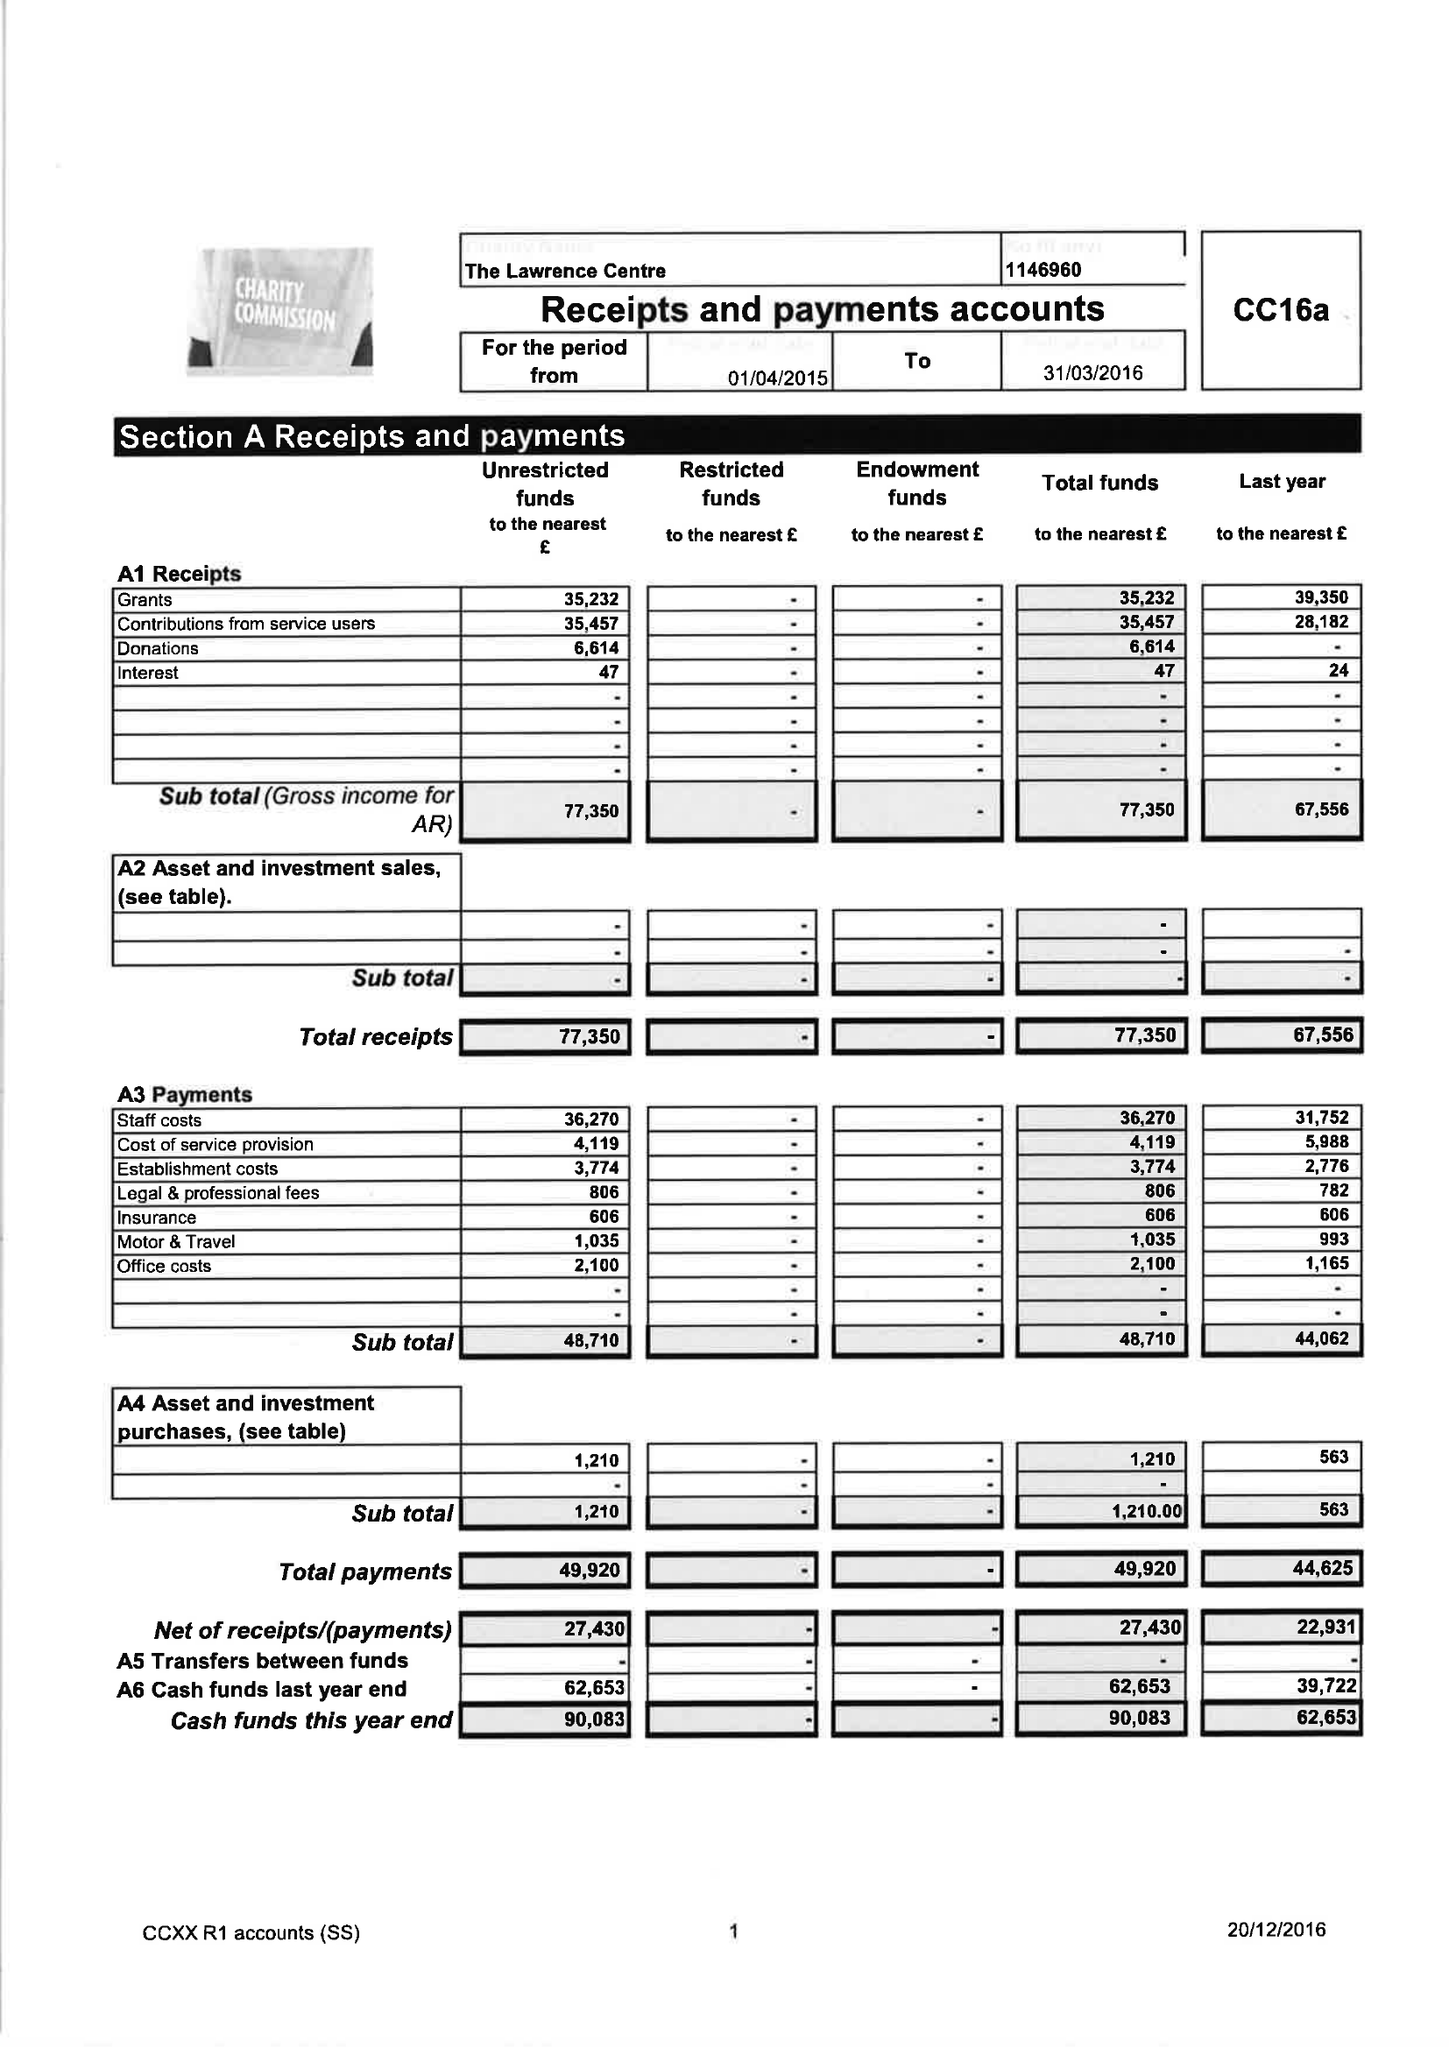What is the value for the spending_annually_in_british_pounds?
Answer the question using a single word or phrase. 48710.00 